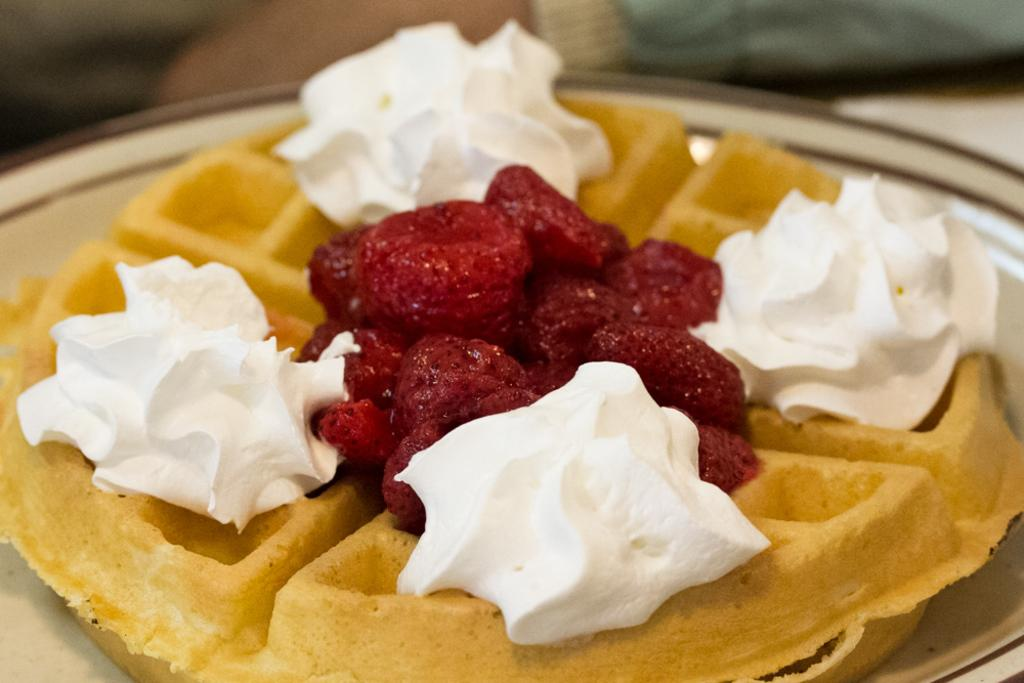What type of food is the main component of the dish in the image? There is a dessert prepared with waffles in the image. Can you describe the dish in more detail? Unfortunately, the provided facts do not offer more information about the dessert. What might be a common topping for a waffle-based dessert? While the facts do not specify any toppings, common toppings for waffle-based desserts include fruits, whipped cream, and syrup. What type of dirt can be seen on the grandfather's shoes in the image? There is no grandfather or dirt present in the image; it only features a dessert prepared with waffles. 